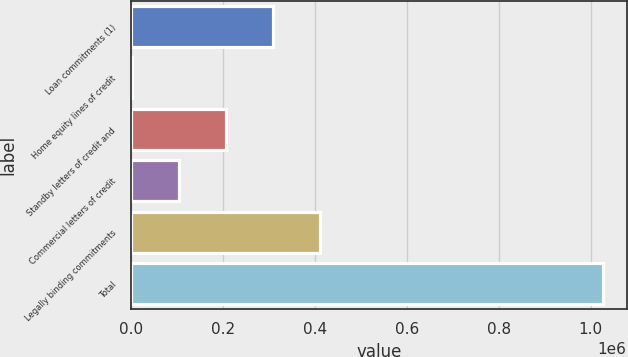<chart> <loc_0><loc_0><loc_500><loc_500><bar_chart><fcel>Loan commitments (1)<fcel>Home equity lines of credit<fcel>Standby letters of credit and<fcel>Commercial letters of credit<fcel>Legally binding commitments<fcel>Total<nl><fcel>309212<fcel>1738<fcel>206720<fcel>104229<fcel>411703<fcel>1.02665e+06<nl></chart> 